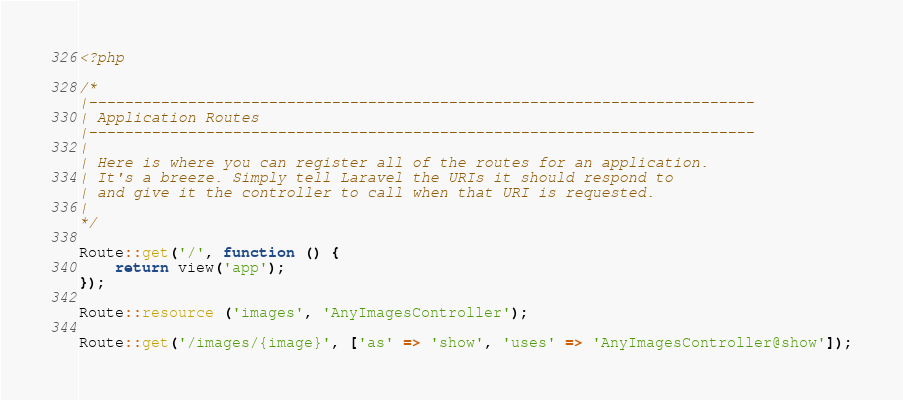Convert code to text. <code><loc_0><loc_0><loc_500><loc_500><_PHP_><?php

/*
|--------------------------------------------------------------------------
| Application Routes
|--------------------------------------------------------------------------
|
| Here is where you can register all of the routes for an application.
| It's a breeze. Simply tell Laravel the URIs it should respond to
| and give it the controller to call when that URI is requested.
|
*/

Route::get('/', function () {
    return view('app');
});

Route::resource ('images', 'AnyImagesController');

Route::get('/images/{image}', ['as' => 'show', 'uses' => 'AnyImagesController@show']);
</code> 